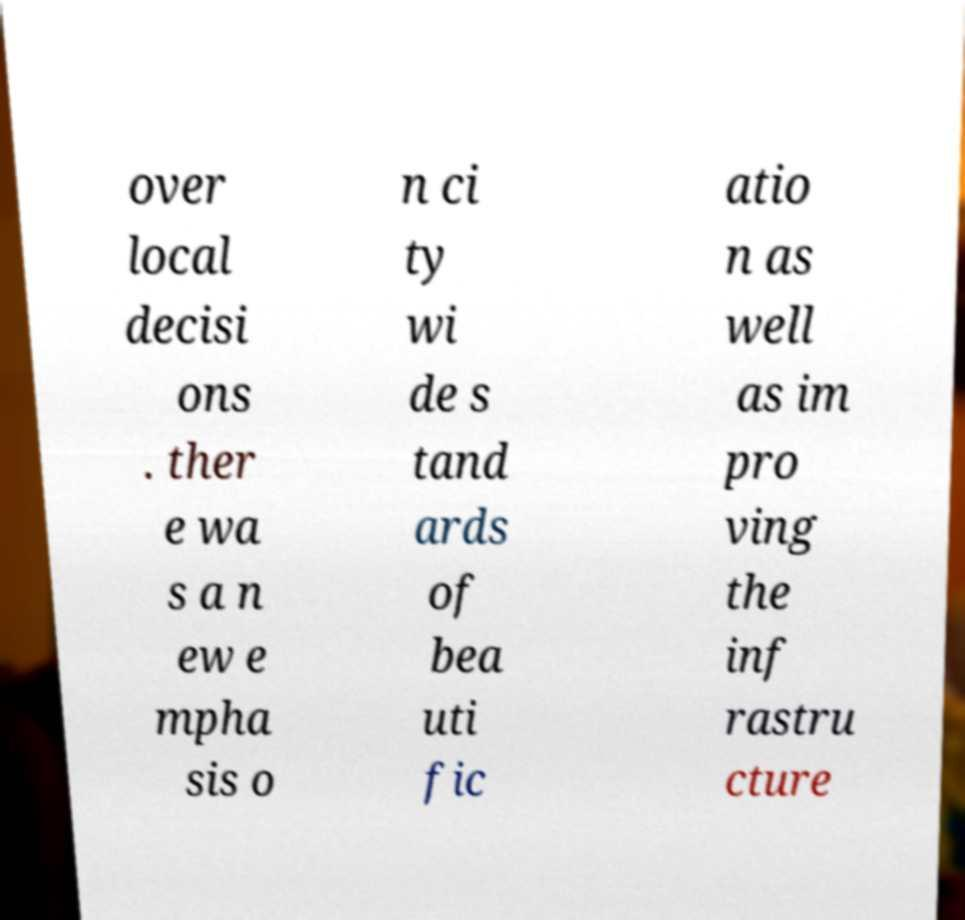Could you assist in decoding the text presented in this image and type it out clearly? over local decisi ons . ther e wa s a n ew e mpha sis o n ci ty wi de s tand ards of bea uti fic atio n as well as im pro ving the inf rastru cture 